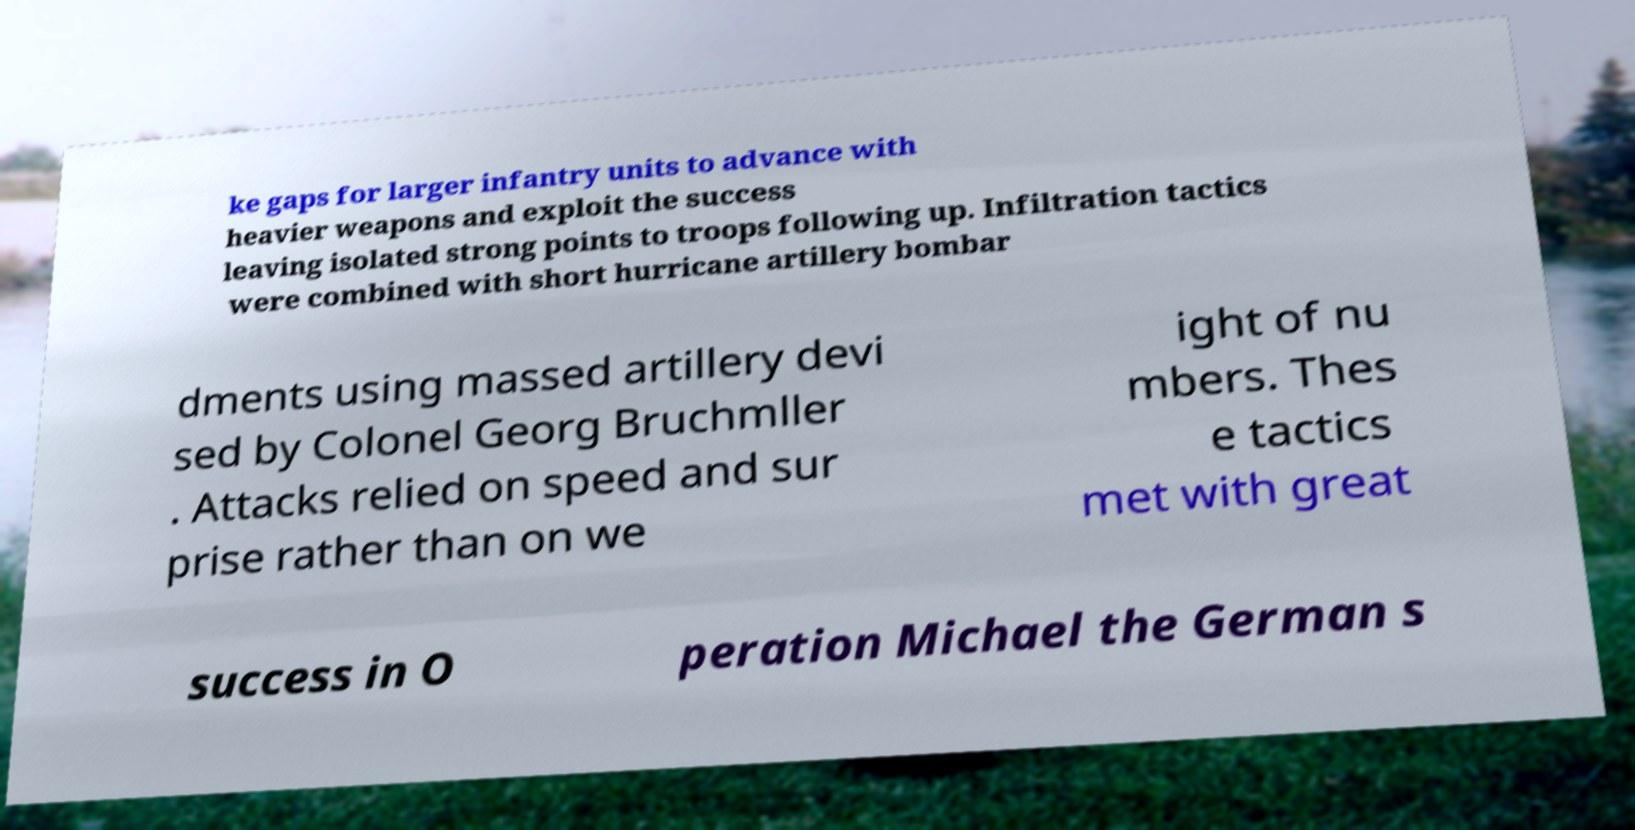Could you assist in decoding the text presented in this image and type it out clearly? ke gaps for larger infantry units to advance with heavier weapons and exploit the success leaving isolated strong points to troops following up. Infiltration tactics were combined with short hurricane artillery bombar dments using massed artillery devi sed by Colonel Georg Bruchmller . Attacks relied on speed and sur prise rather than on we ight of nu mbers. Thes e tactics met with great success in O peration Michael the German s 